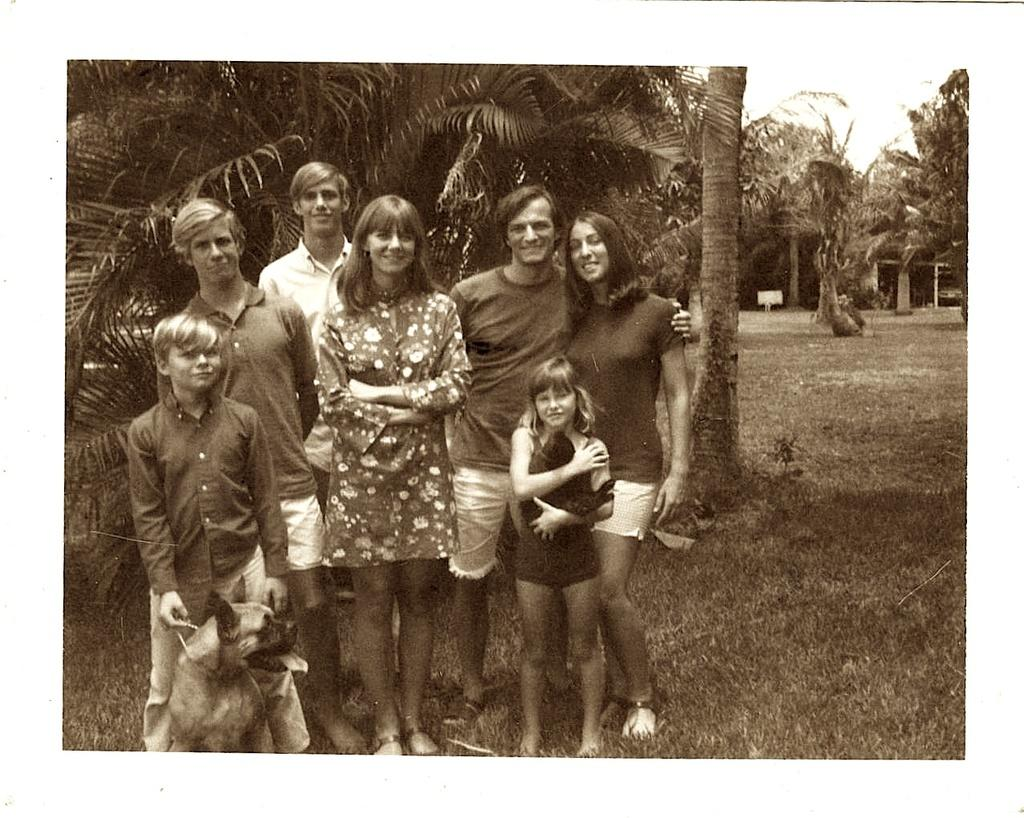What can be seen on the surface in the image? There are people standing on the surface in the image. What type of vegetation is visible in the image? There are trees visible in the image. What other living beings can be seen in the image besides people? There are animals in the image. What type of drain is visible in the image? There is no drain present in the image. Can you tell me which pencil is being used by the animals in the image? There are no pencils or animals using pencils in the image. 